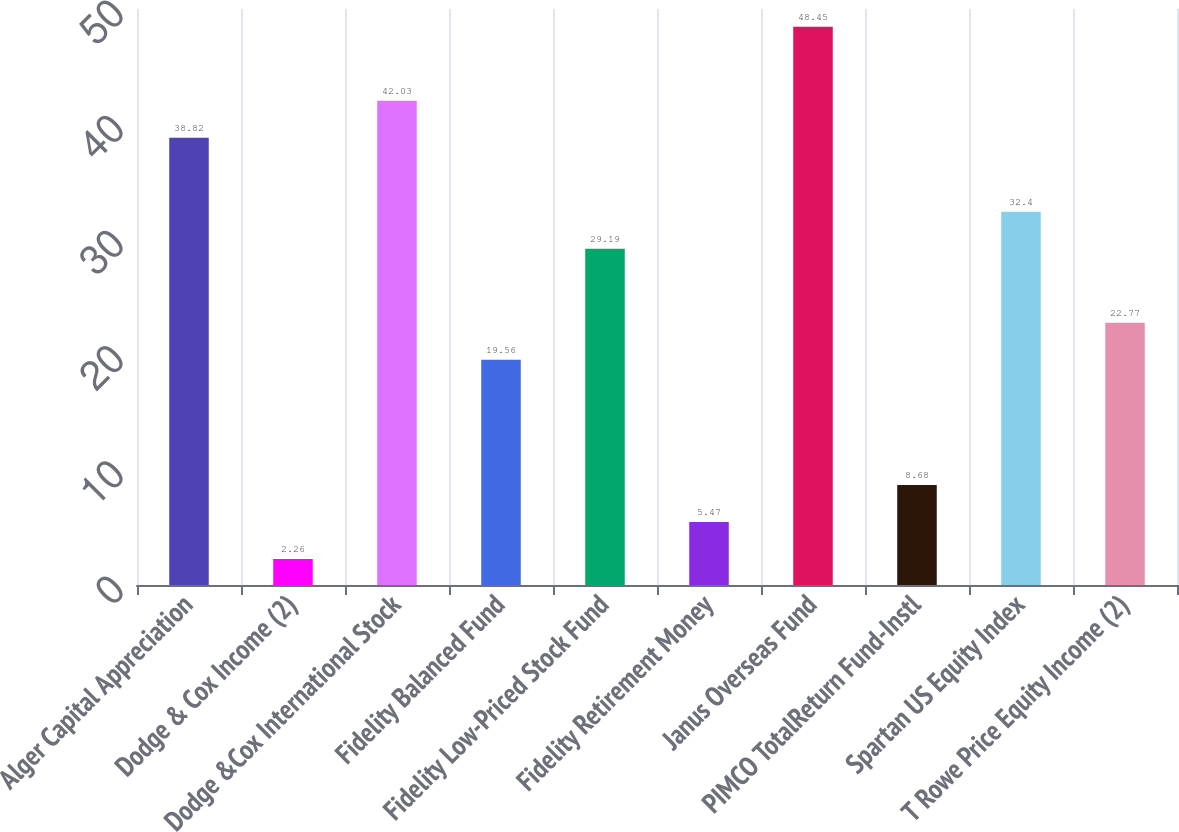Convert chart to OTSL. <chart><loc_0><loc_0><loc_500><loc_500><bar_chart><fcel>Alger Capital Appreciation<fcel>Dodge & Cox Income (2)<fcel>Dodge &Cox International Stock<fcel>Fidelity Balanced Fund<fcel>Fidelity Low-Priced Stock Fund<fcel>Fidelity Retirement Money<fcel>Janus Overseas Fund<fcel>PIMCO TotalReturn Fund-Instl<fcel>Spartan US Equity Index<fcel>T Rowe Price Equity Income (2)<nl><fcel>38.82<fcel>2.26<fcel>42.03<fcel>19.56<fcel>29.19<fcel>5.47<fcel>48.45<fcel>8.68<fcel>32.4<fcel>22.77<nl></chart> 